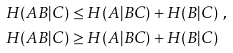<formula> <loc_0><loc_0><loc_500><loc_500>H ( A B | C ) & \leq H ( A | B C ) + H ( B | C ) \ , \\ H ( A B | C ) & \geq H ( A | B C ) + H ( B | C )</formula> 